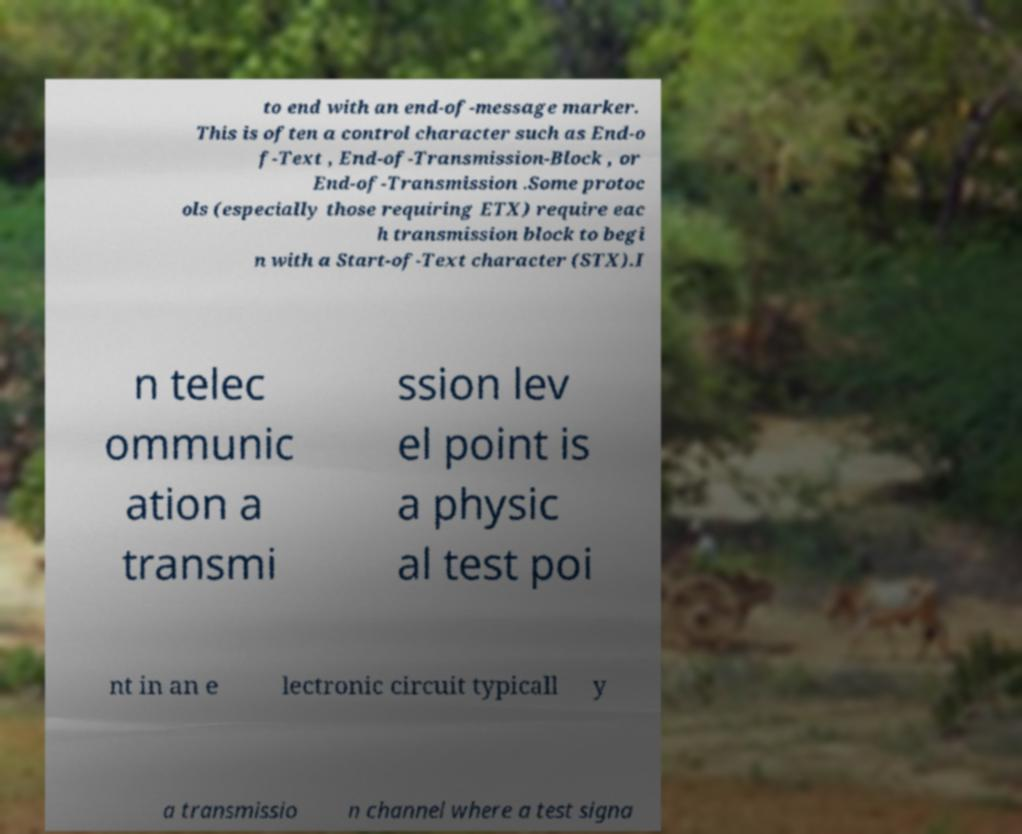For documentation purposes, I need the text within this image transcribed. Could you provide that? to end with an end-of-message marker. This is often a control character such as End-o f-Text , End-of-Transmission-Block , or End-of-Transmission .Some protoc ols (especially those requiring ETX) require eac h transmission block to begi n with a Start-of-Text character (STX).I n telec ommunic ation a transmi ssion lev el point is a physic al test poi nt in an e lectronic circuit typicall y a transmissio n channel where a test signa 